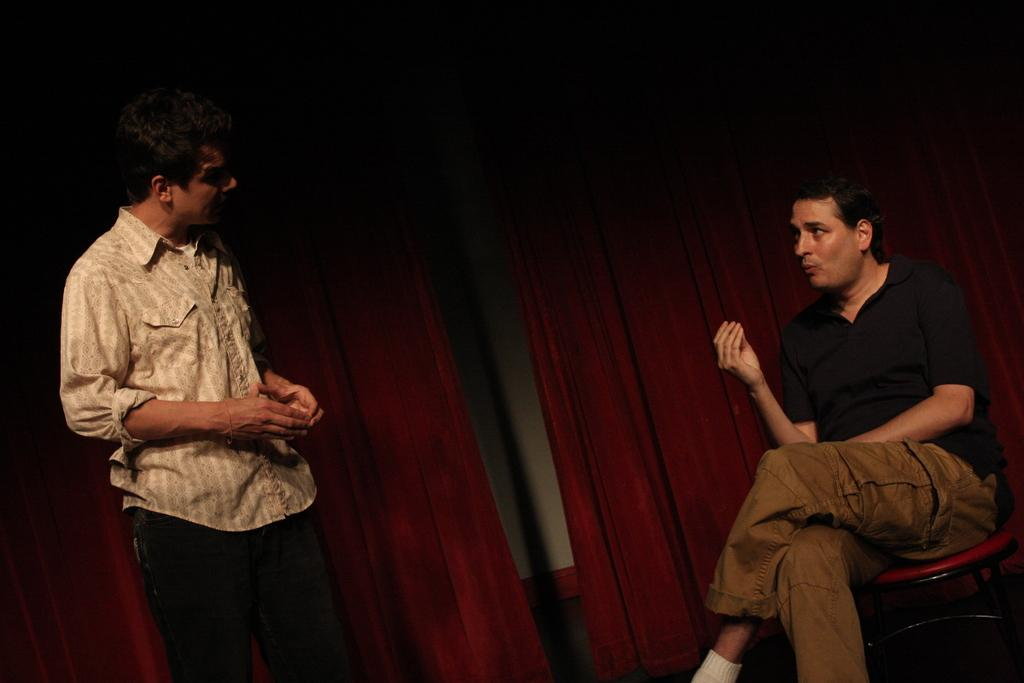What is the primary action of the person in the image? The person in the image is sitting in a chair. Who is the person in the image interacting with? The person is speaking to another person in front of them. What can be seen in the background behind the two people? There are curtains visible behind the two people. What type of grass is growing on the father's head in the image? There is no father or grass present in the image. 